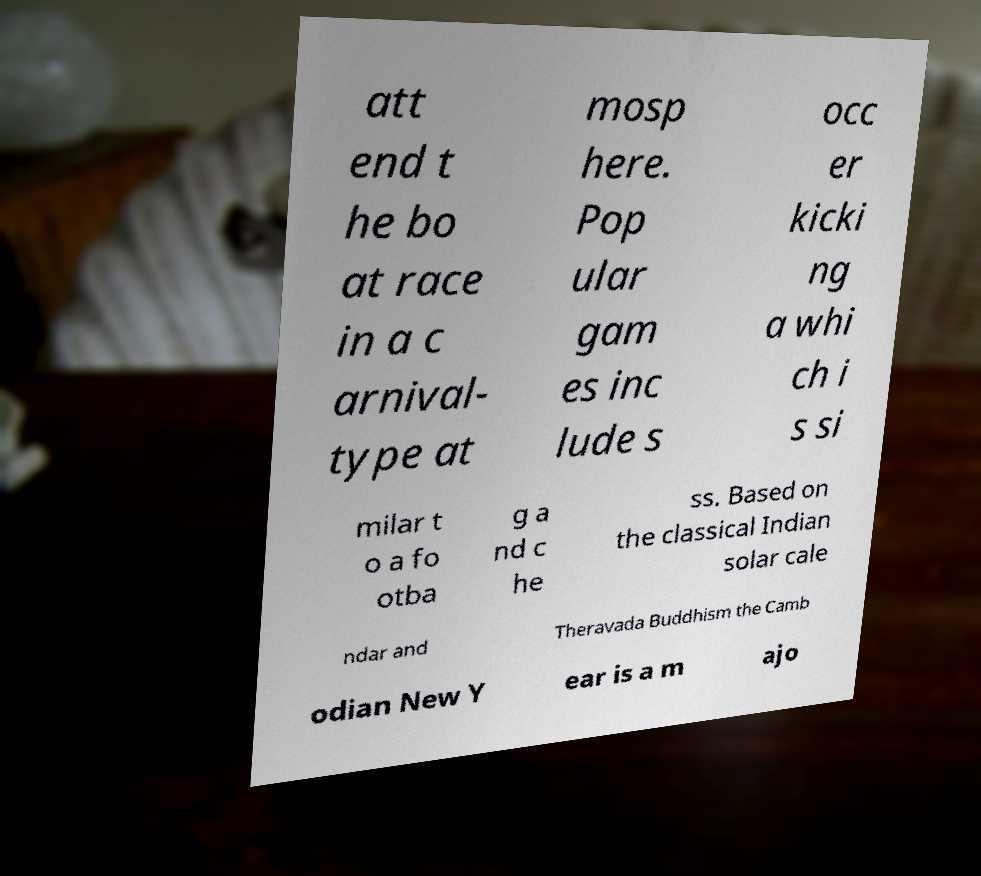Please identify and transcribe the text found in this image. att end t he bo at race in a c arnival- type at mosp here. Pop ular gam es inc lude s occ er kicki ng a whi ch i s si milar t o a fo otba g a nd c he ss. Based on the classical Indian solar cale ndar and Theravada Buddhism the Camb odian New Y ear is a m ajo 